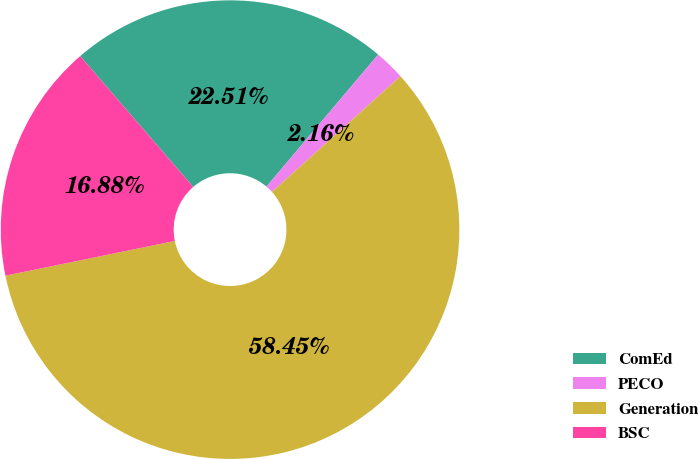Convert chart. <chart><loc_0><loc_0><loc_500><loc_500><pie_chart><fcel>ComEd<fcel>PECO<fcel>Generation<fcel>BSC<nl><fcel>22.51%<fcel>2.16%<fcel>58.44%<fcel>16.88%<nl></chart> 